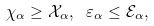Convert formula to latex. <formula><loc_0><loc_0><loc_500><loc_500>\chi _ { \alpha } \geq { \mathcal { X } } _ { \alpha } , \ \varepsilon _ { \alpha } \leq { \mathcal { E } } _ { \alpha } ,</formula> 